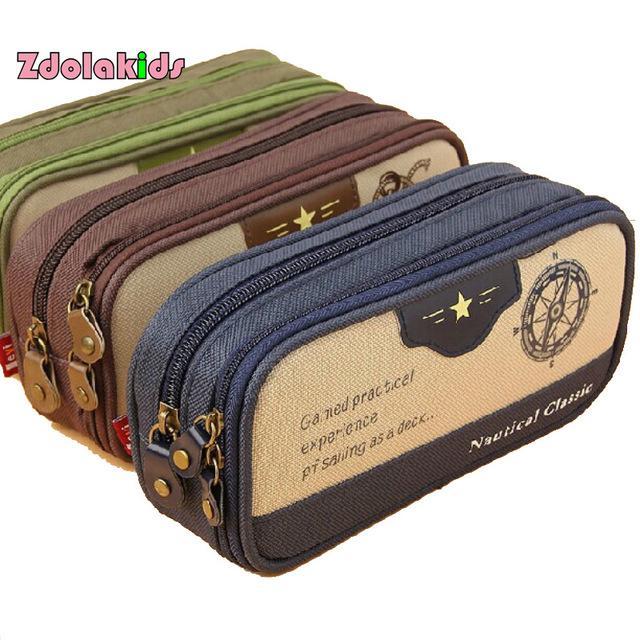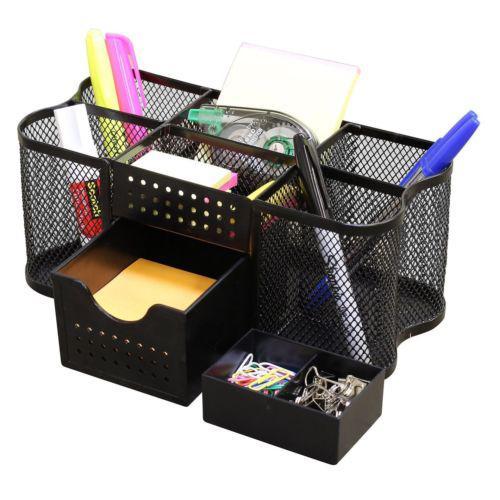The first image is the image on the left, the second image is the image on the right. For the images shown, is this caption "Exactly one bag is closed." true? Answer yes or no. No. The first image is the image on the left, the second image is the image on the right. Examine the images to the left and right. Is the description "Only pencil cases with zipper closures are shown, at least one case is hot pink, one case is closed, and at least one case is open." accurate? Answer yes or no. No. 